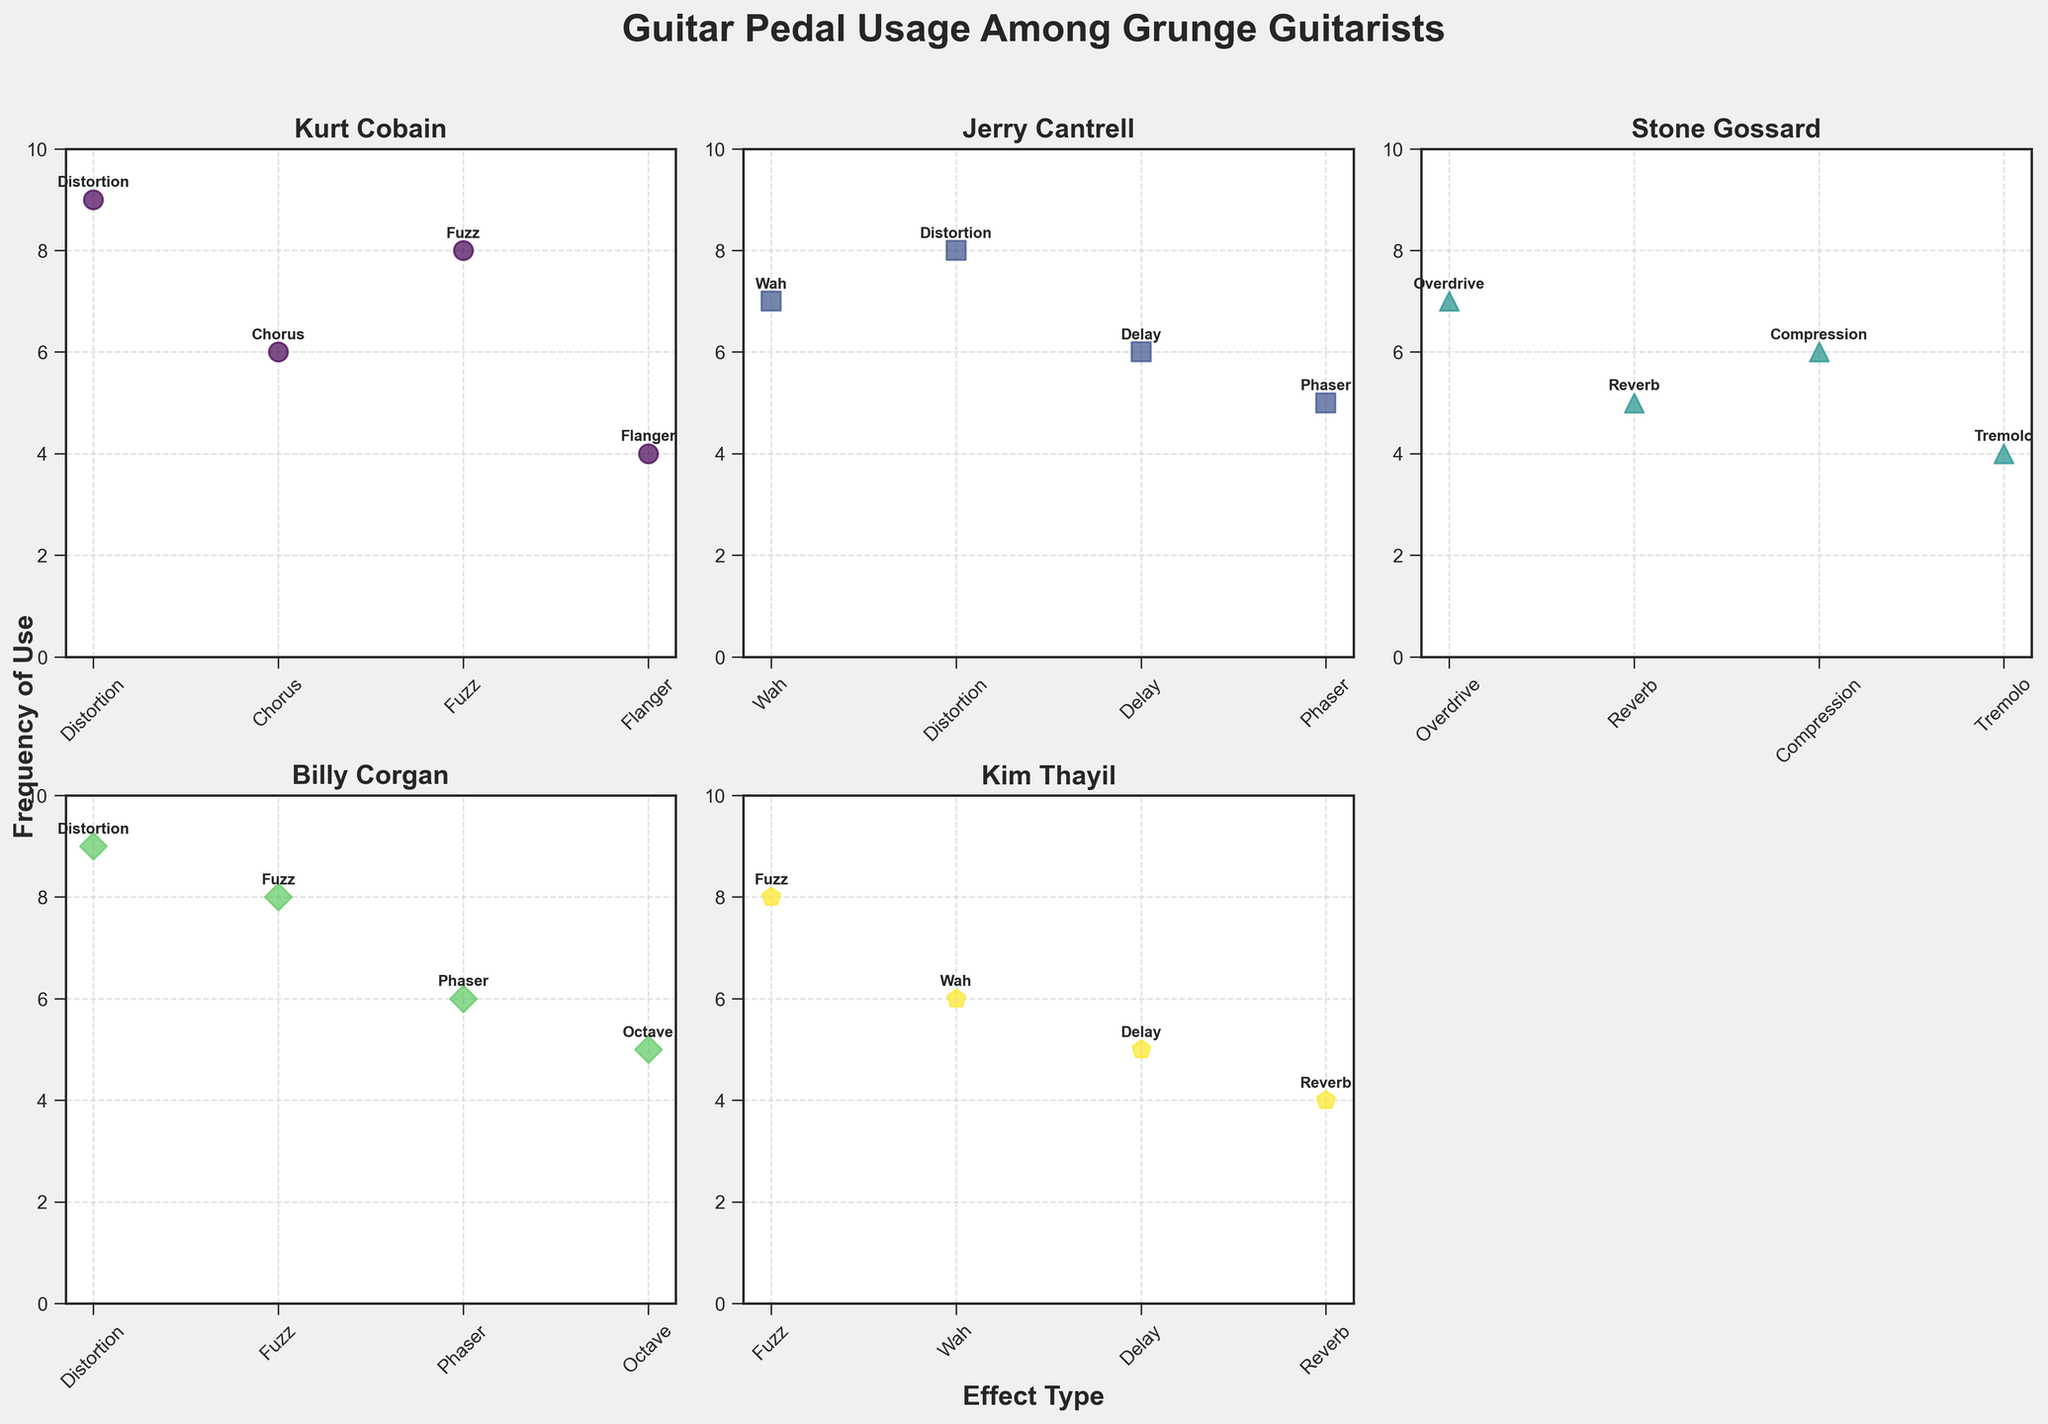What's the title of the figure? The title is located at the top center of the figure and is usually presented in a larger and bold font.
Answer: Guitar Pedal Usage Among Grunge Guitarists How many effect types did Kurt Cobain use? To determine this, look at the scatter plot titled "Kurt Cobain" and count the unique data points representing different effect types.
Answer: 4 Which guitarist has the highest frequency of using Distortion? Check the scatter plots for each guitarist and locate the frequency of use for "Distortion" effect type. Kurt Cobain and Billy Corgan both used it 9 times, which is the highest.
Answer: Kurt Cobain and Billy Corgan What is the average frequency of use for effect types used by Jerry Cantrell? Locate Jerry Cantrell's scatter plot and identify the frequencies (7, 8, 6, 5). Sum these frequencies (7 + 8 + 6 + 5 = 26) and divide by the number of effect types (4).
Answer: 6.5 Which effect type appears most frequently across all guitarists? Review all the scatter plots, count the occurrences of each effect type, and identify the one with the highest total. Fuzz appears 4 times (Kurt Cobain, Billy Corgan, and Kim Thayil twice).
Answer: Fuzz How does Stone Gossard's use of Overdrive compare to Kim Thayil's use of Fuzz? Locate the respective scatter plots and compare the frequency of use. Stone Gossard used Overdrive 7 times, while Kim Thayil used Fuzz 8 times.
Answer: Kim Thayil's use of Fuzz is higher What's the difference in the number of effects used by Kurt Cobain and Stone Gossard? Count the number of unique effect types for Kurt Cobain (4) and Stone Gossard (4). The difference is 4 - 4.
Answer: 0 Which guitarist used the Reverb effect type the least, and what is the frequency? Review the scatter plots for each guitarist and locate the frequency of "Reverb". Stone Gossard and Kim Thayil both used it 4 times, which is the least.
Answer: Stone Gossard and Kim Thayil, 4 What is the total number of different effect types used by all guitarists combined? Count the unique effect types from all guitarists' scatter plots. There are Distortion, Chorus, Fuzz, Flanger, Wah, Delay, Phaser, Overdrive, Reverb, Compression, Tremolo, and Octave (12 in total).
Answer: 12 